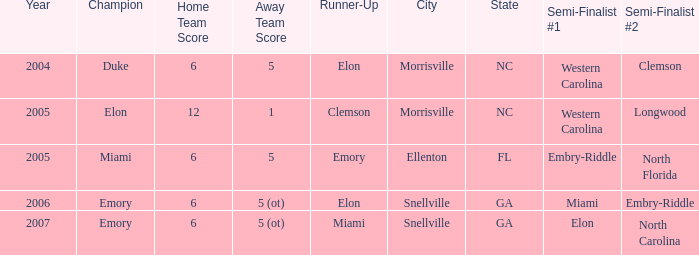Where was the final game played in 2007 Snellville, GA. 